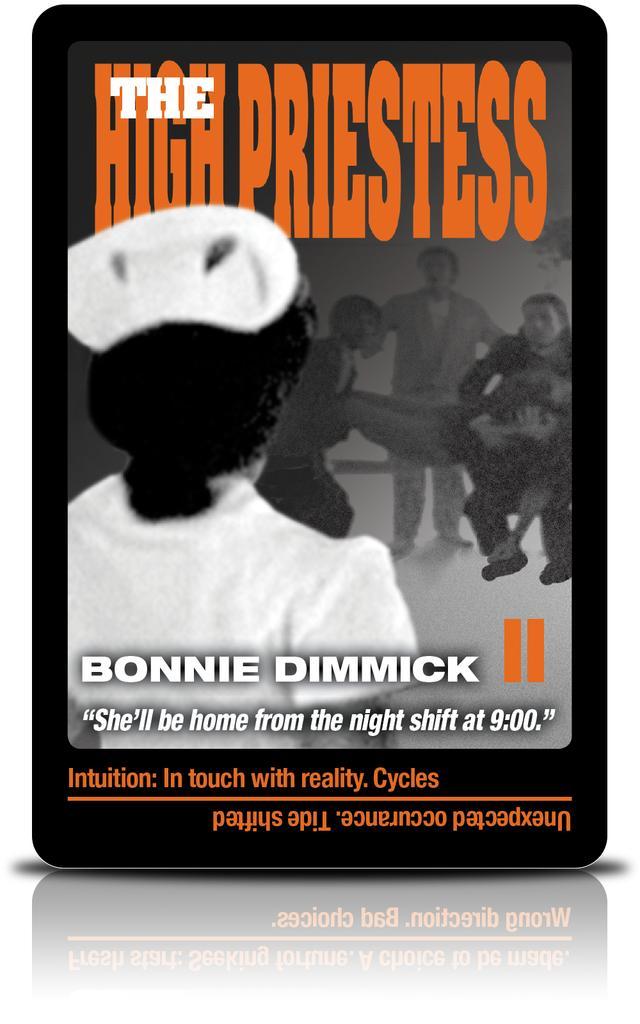In one or two sentences, can you explain what this image depicts? This looks like a poster. I can see letters and people in the poster. I can see the reflection of the poster. 